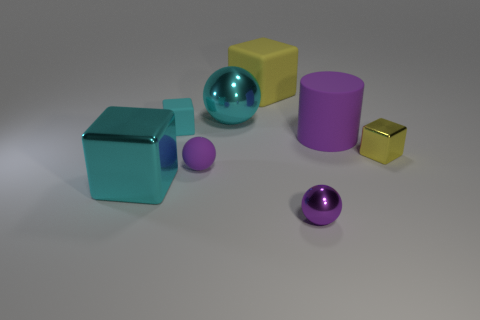Subtract all big rubber blocks. How many blocks are left? 3 Subtract all cylinders. How many objects are left? 7 Add 2 tiny purple rubber spheres. How many objects exist? 10 Subtract all cyan spheres. How many spheres are left? 2 Add 4 purple metallic spheres. How many purple metallic spheres are left? 5 Add 7 big purple rubber objects. How many big purple rubber objects exist? 8 Subtract 2 purple spheres. How many objects are left? 6 Subtract 1 spheres. How many spheres are left? 2 Subtract all purple spheres. Subtract all gray cylinders. How many spheres are left? 1 Subtract all gray cylinders. How many cyan blocks are left? 2 